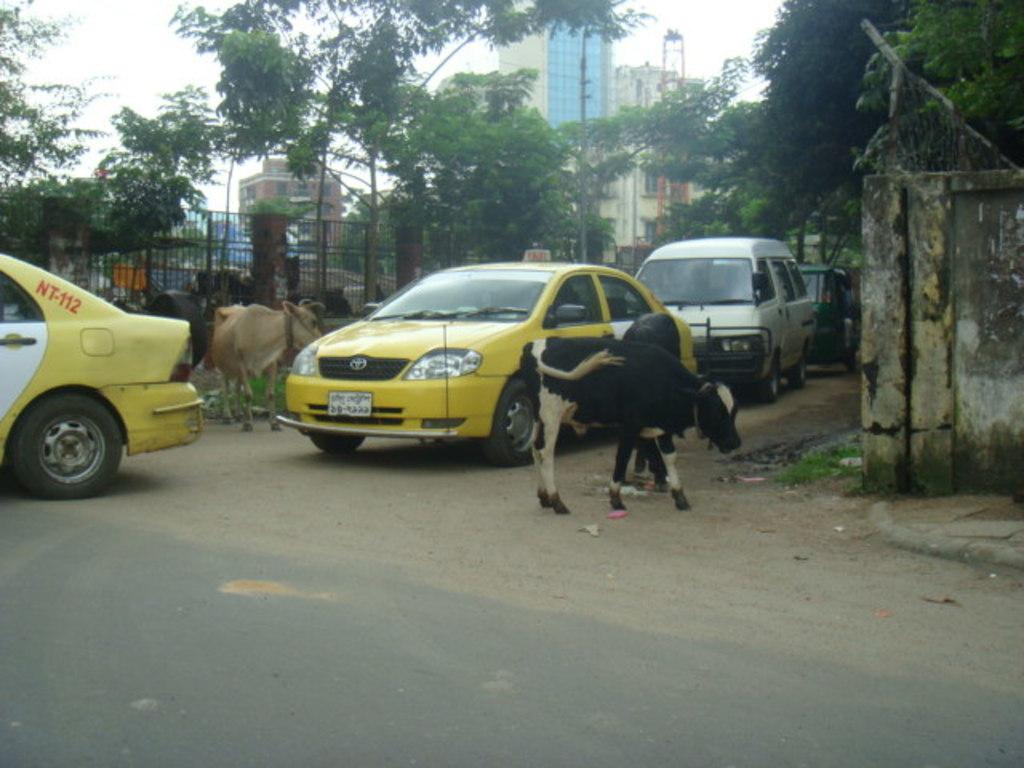What brand of car is the yellow taxi?
Your answer should be very brief. Toyota. 